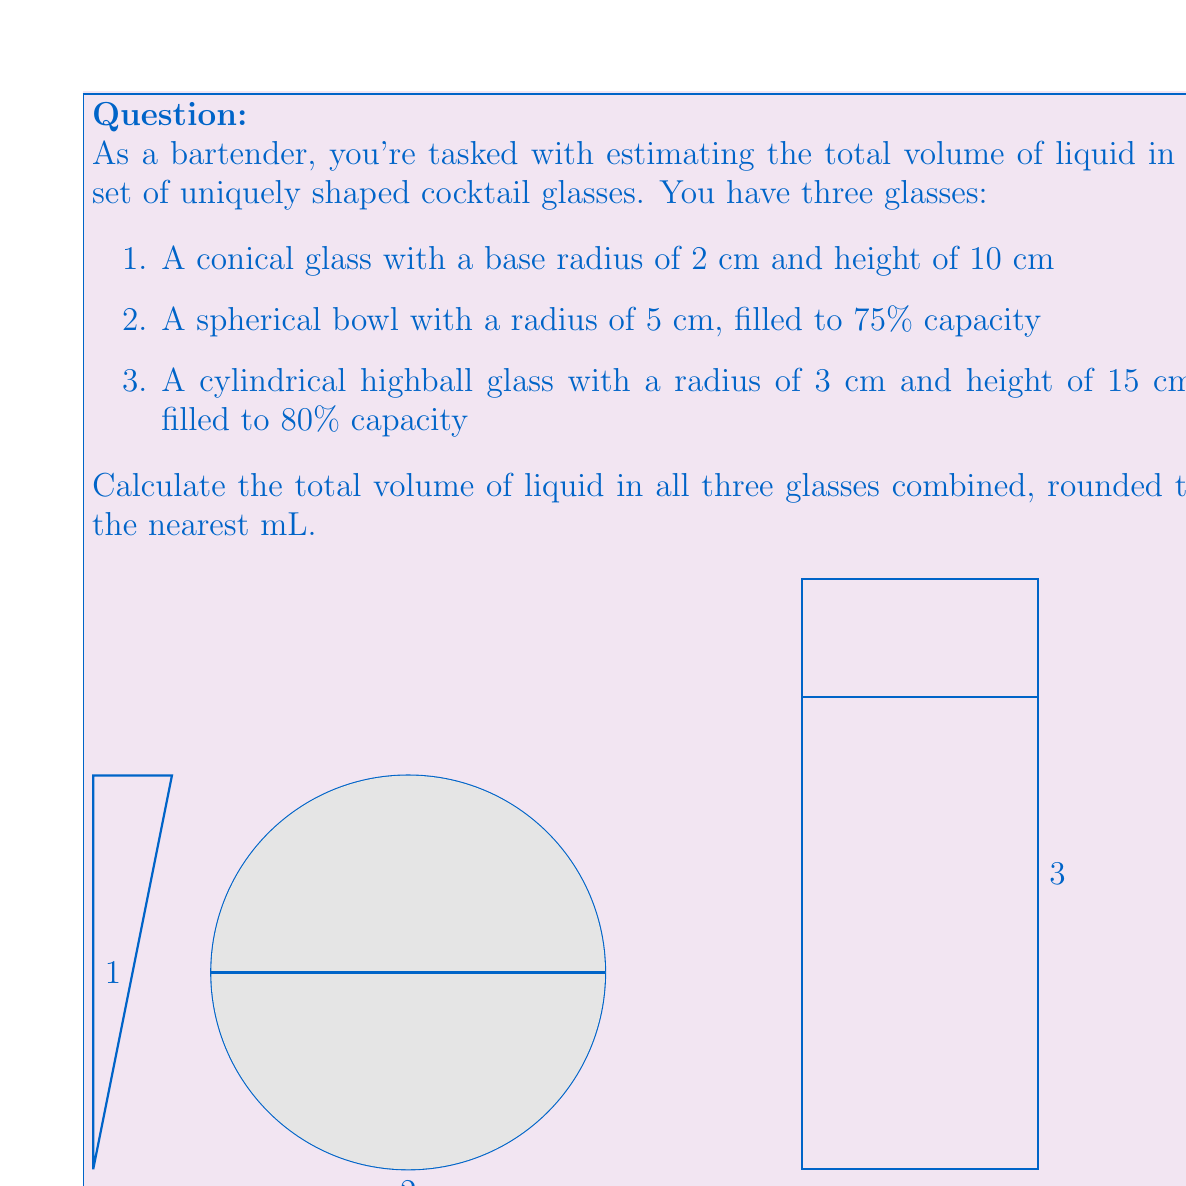Help me with this question. Let's calculate the volume of liquid in each glass step by step:

1. Conical glass:
   The volume of a cone is given by $V = \frac{1}{3}\pi r^2 h$
   $$V_1 = \frac{1}{3} \pi (2\text{ cm})^2 (10\text{ cm}) = \frac{40\pi}{3} \approx 41.89 \text{ cm}^3$$

2. Spherical bowl:
   The volume of a sphere is $V = \frac{4}{3}\pi r^3$, but it's only 75% full
   $$V_2 = 0.75 \cdot \frac{4}{3}\pi (5\text{ cm})^3 = 250\pi \approx 785.40 \text{ cm}^3$$

3. Cylindrical highball glass:
   The volume of a cylinder is $V = \pi r^2 h$, but it's only 80% full
   $$V_3 = 0.80 \cdot \pi (3\text{ cm})^2 (15\text{ cm}) = 108\pi \approx 339.29 \text{ cm}^3$$

Total volume:
$$V_{\text{total}} = V_1 + V_2 + V_3 = \frac{40\pi}{3} + 250\pi + 108\pi \approx 1166.58 \text{ cm}^3$$

Converting to mL (1 cm³ = 1 mL) and rounding to the nearest mL:
$$V_{\text{total}} \approx 1167 \text{ mL}$$
Answer: 1167 mL 